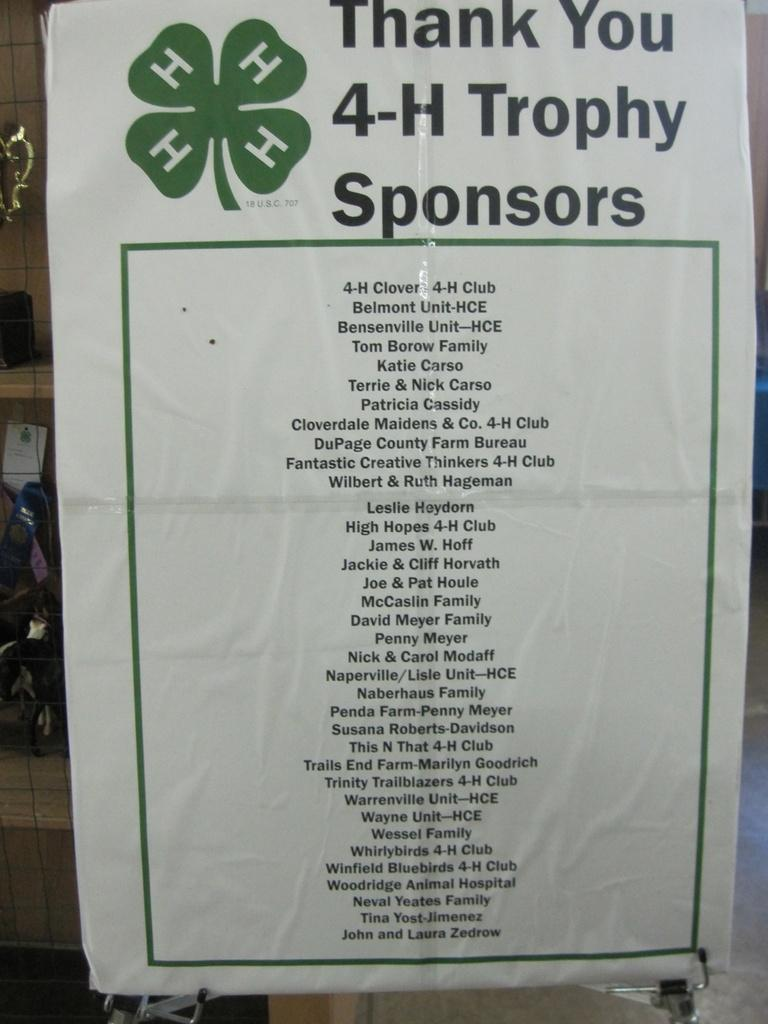<image>
Write a terse but informative summary of the picture. Sign that has a clover and says "Thank You 4-H Trophy Sponsors". 